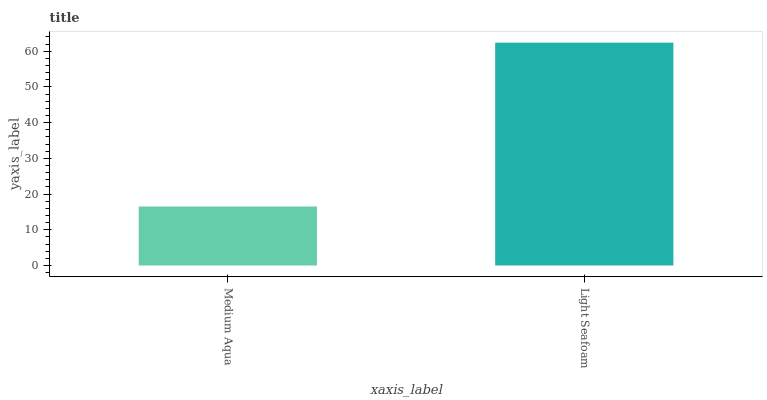Is Light Seafoam the minimum?
Answer yes or no. No. Is Light Seafoam greater than Medium Aqua?
Answer yes or no. Yes. Is Medium Aqua less than Light Seafoam?
Answer yes or no. Yes. Is Medium Aqua greater than Light Seafoam?
Answer yes or no. No. Is Light Seafoam less than Medium Aqua?
Answer yes or no. No. Is Light Seafoam the high median?
Answer yes or no. Yes. Is Medium Aqua the low median?
Answer yes or no. Yes. Is Medium Aqua the high median?
Answer yes or no. No. Is Light Seafoam the low median?
Answer yes or no. No. 